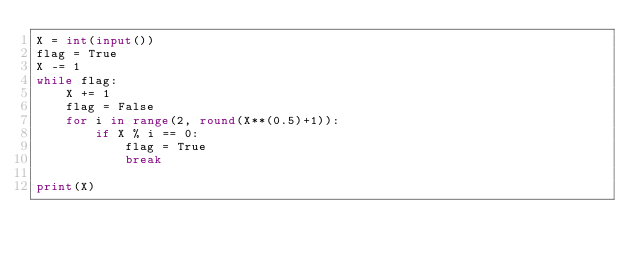Convert code to text. <code><loc_0><loc_0><loc_500><loc_500><_Python_>X = int(input())
flag = True
X -= 1
while flag:
    X += 1
    flag = False
    for i in range(2, round(X**(0.5)+1)):
        if X % i == 0:
            flag = True
            break
        
print(X)</code> 